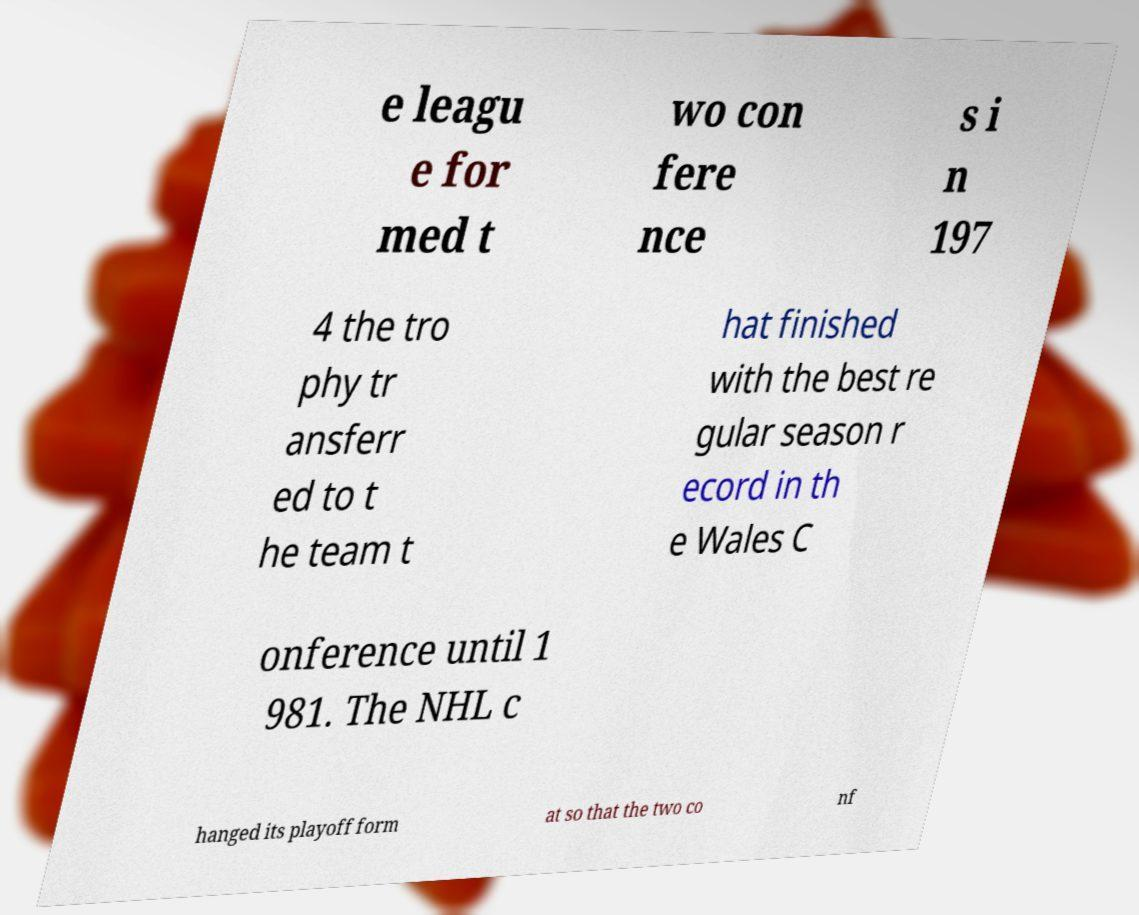Can you accurately transcribe the text from the provided image for me? e leagu e for med t wo con fere nce s i n 197 4 the tro phy tr ansferr ed to t he team t hat finished with the best re gular season r ecord in th e Wales C onference until 1 981. The NHL c hanged its playoff form at so that the two co nf 